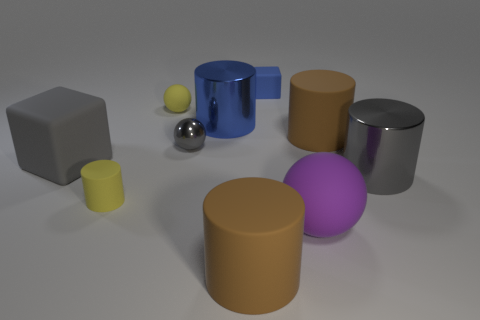Is the gray object that is in front of the gray rubber object made of the same material as the cube left of the blue metallic cylinder?
Make the answer very short. No. What number of yellow matte objects are to the right of the brown cylinder on the right side of the big brown cylinder that is on the left side of the small matte cube?
Offer a terse response. 0. Do the large shiny cylinder that is on the right side of the tiny blue matte cube and the large cylinder in front of the yellow cylinder have the same color?
Your answer should be compact. No. Are there any other things that are the same color as the tiny matte block?
Offer a terse response. Yes. There is a shiny cylinder that is behind the shiny thing that is to the right of the big blue cylinder; what is its color?
Make the answer very short. Blue. Are any yellow cylinders visible?
Make the answer very short. Yes. What color is the big rubber object that is right of the small rubber cylinder and on the left side of the big sphere?
Provide a succinct answer. Brown. There is a sphere behind the large blue cylinder; does it have the same size as the brown cylinder that is to the right of the large purple sphere?
Offer a very short reply. No. What number of other objects are the same size as the blue metallic object?
Your response must be concise. 5. How many big metal things are left of the brown object in front of the large block?
Provide a succinct answer. 1. 